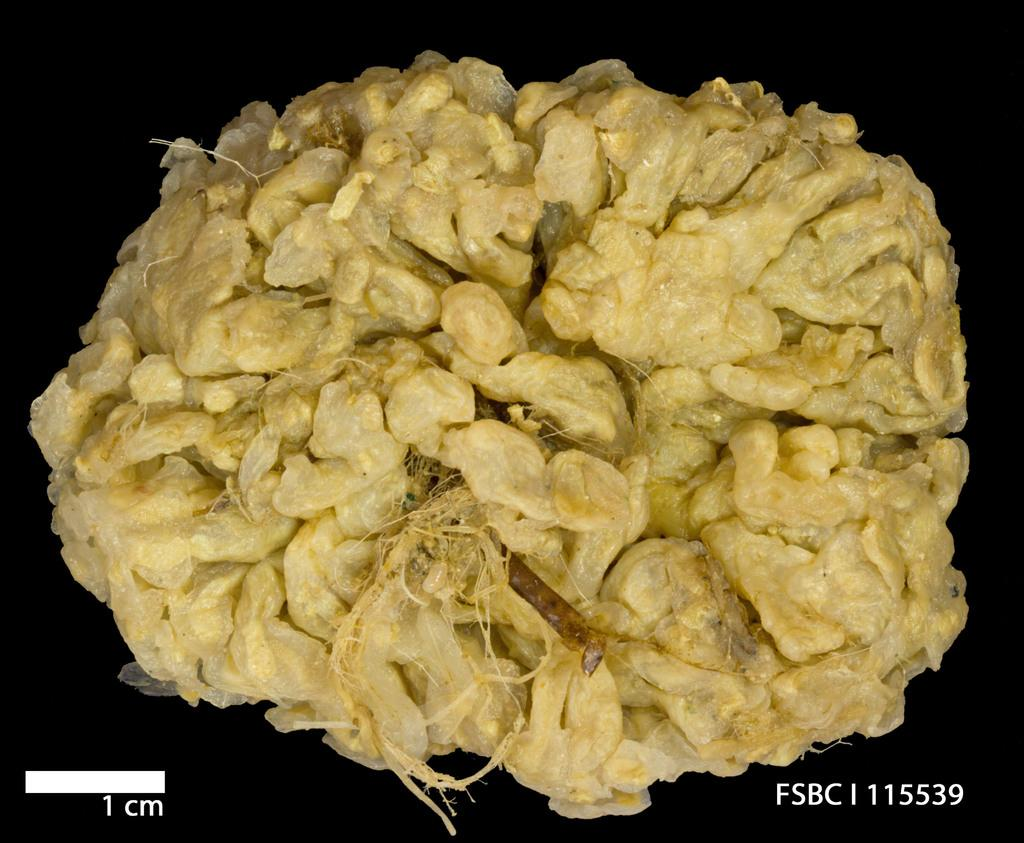What can be seen in the image related to food? There is food in the image. What type of parcel can be seen being traded in the image? There is no parcel or trade activity present in the image; it only features food. What is the acoustics like in the image? The provided facts do not mention anything about the acoustics or sound in the image, so it cannot be determined from the image. 